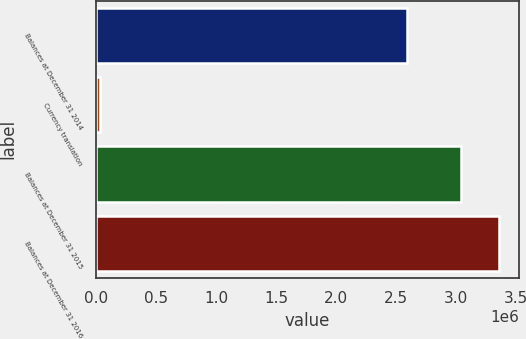<chart> <loc_0><loc_0><loc_500><loc_500><bar_chart><fcel>Balances at December 31 2014<fcel>Currency translation<fcel>Balances at December 31 2015<fcel>Balances at December 31 2016<nl><fcel>2.59436e+06<fcel>31556<fcel>3.0392e+06<fcel>3.35455e+06<nl></chart> 